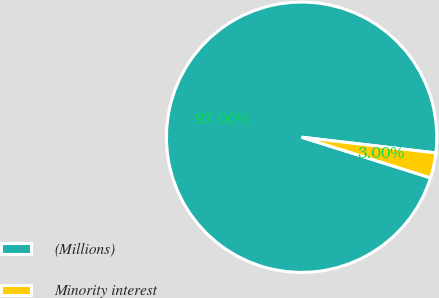Convert chart to OTSL. <chart><loc_0><loc_0><loc_500><loc_500><pie_chart><fcel>(Millions)<fcel>Minority interest<nl><fcel>97.0%<fcel>3.0%<nl></chart> 